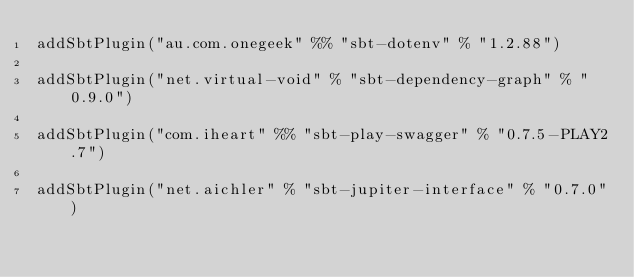<code> <loc_0><loc_0><loc_500><loc_500><_Scala_>addSbtPlugin("au.com.onegeek" %% "sbt-dotenv" % "1.2.88")

addSbtPlugin("net.virtual-void" % "sbt-dependency-graph" % "0.9.0")

addSbtPlugin("com.iheart" %% "sbt-play-swagger" % "0.7.5-PLAY2.7")

addSbtPlugin("net.aichler" % "sbt-jupiter-interface" % "0.7.0")
</code> 